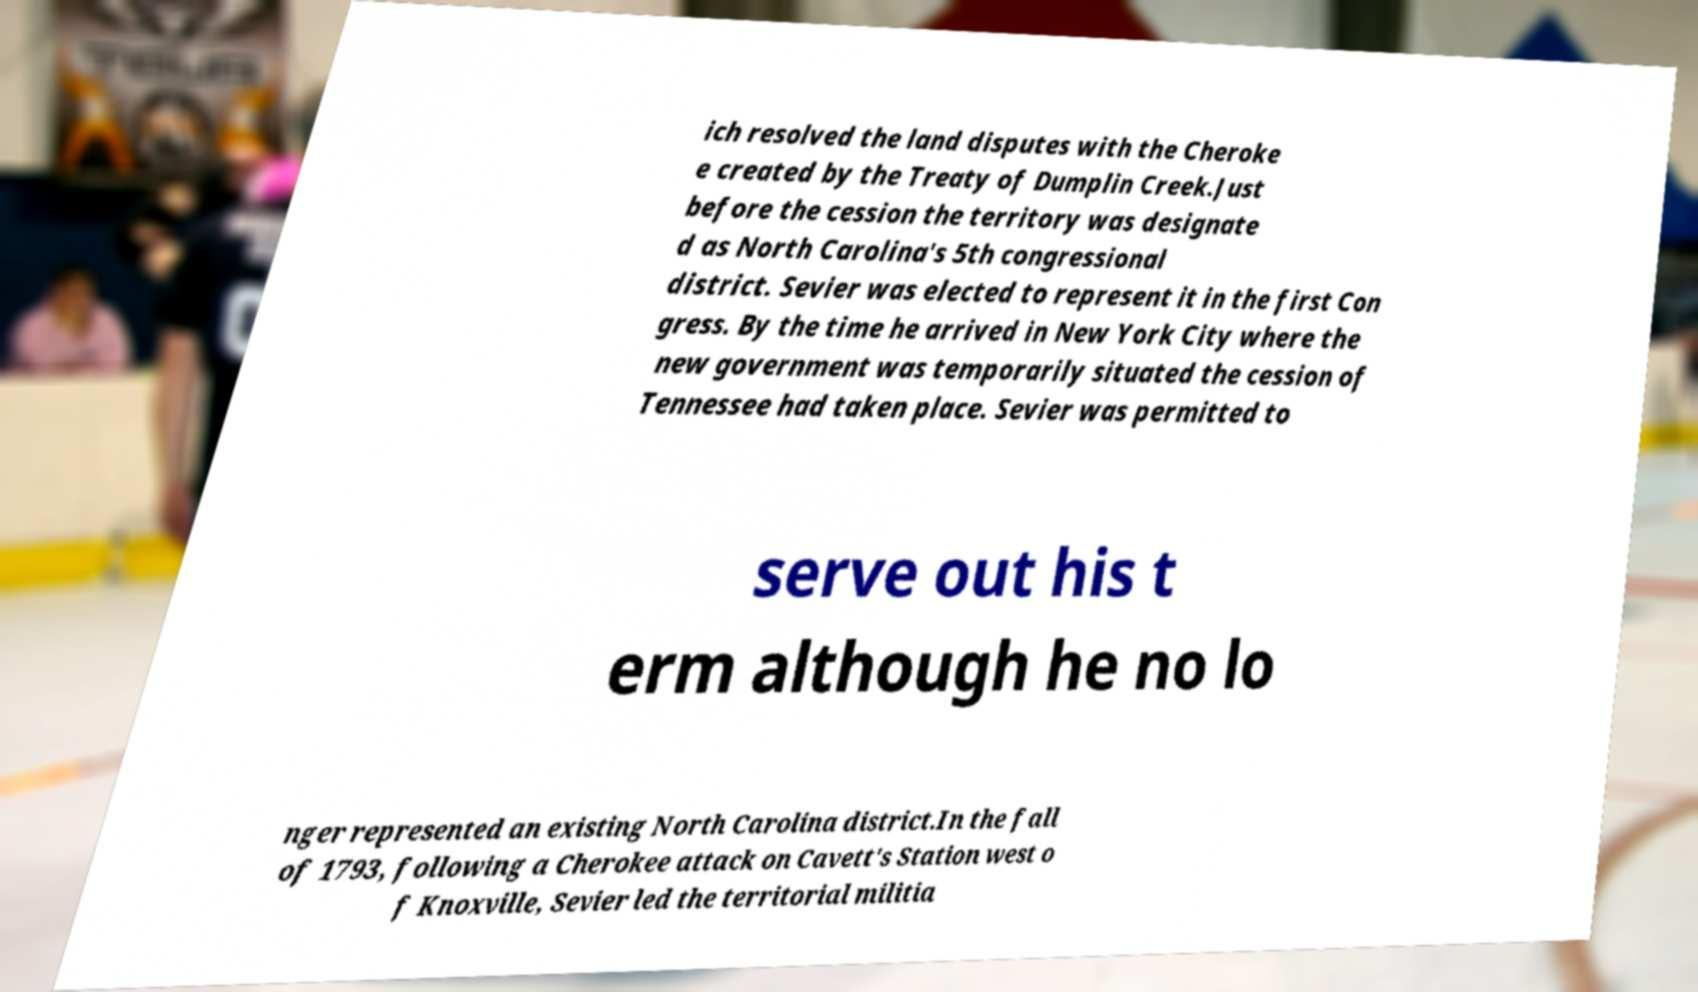What messages or text are displayed in this image? I need them in a readable, typed format. ich resolved the land disputes with the Cheroke e created by the Treaty of Dumplin Creek.Just before the cession the territory was designate d as North Carolina's 5th congressional district. Sevier was elected to represent it in the first Con gress. By the time he arrived in New York City where the new government was temporarily situated the cession of Tennessee had taken place. Sevier was permitted to serve out his t erm although he no lo nger represented an existing North Carolina district.In the fall of 1793, following a Cherokee attack on Cavett's Station west o f Knoxville, Sevier led the territorial militia 